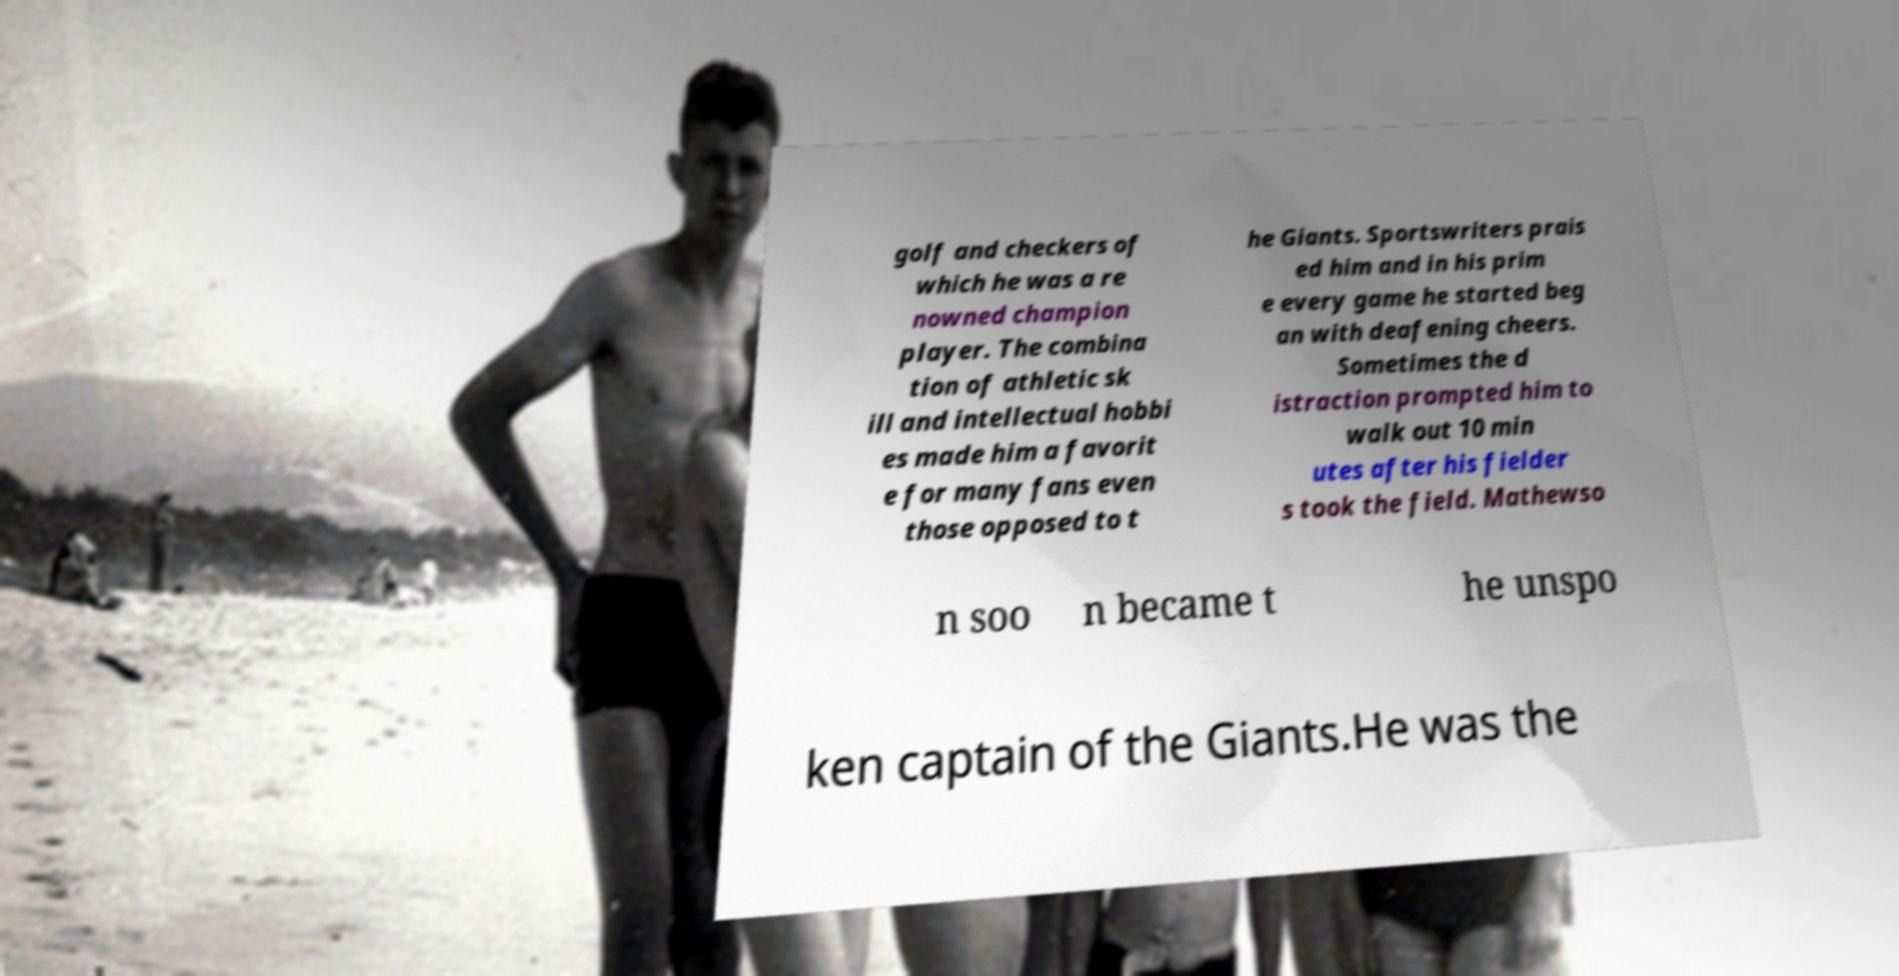Can you accurately transcribe the text from the provided image for me? golf and checkers of which he was a re nowned champion player. The combina tion of athletic sk ill and intellectual hobbi es made him a favorit e for many fans even those opposed to t he Giants. Sportswriters prais ed him and in his prim e every game he started beg an with deafening cheers. Sometimes the d istraction prompted him to walk out 10 min utes after his fielder s took the field. Mathewso n soo n became t he unspo ken captain of the Giants.He was the 